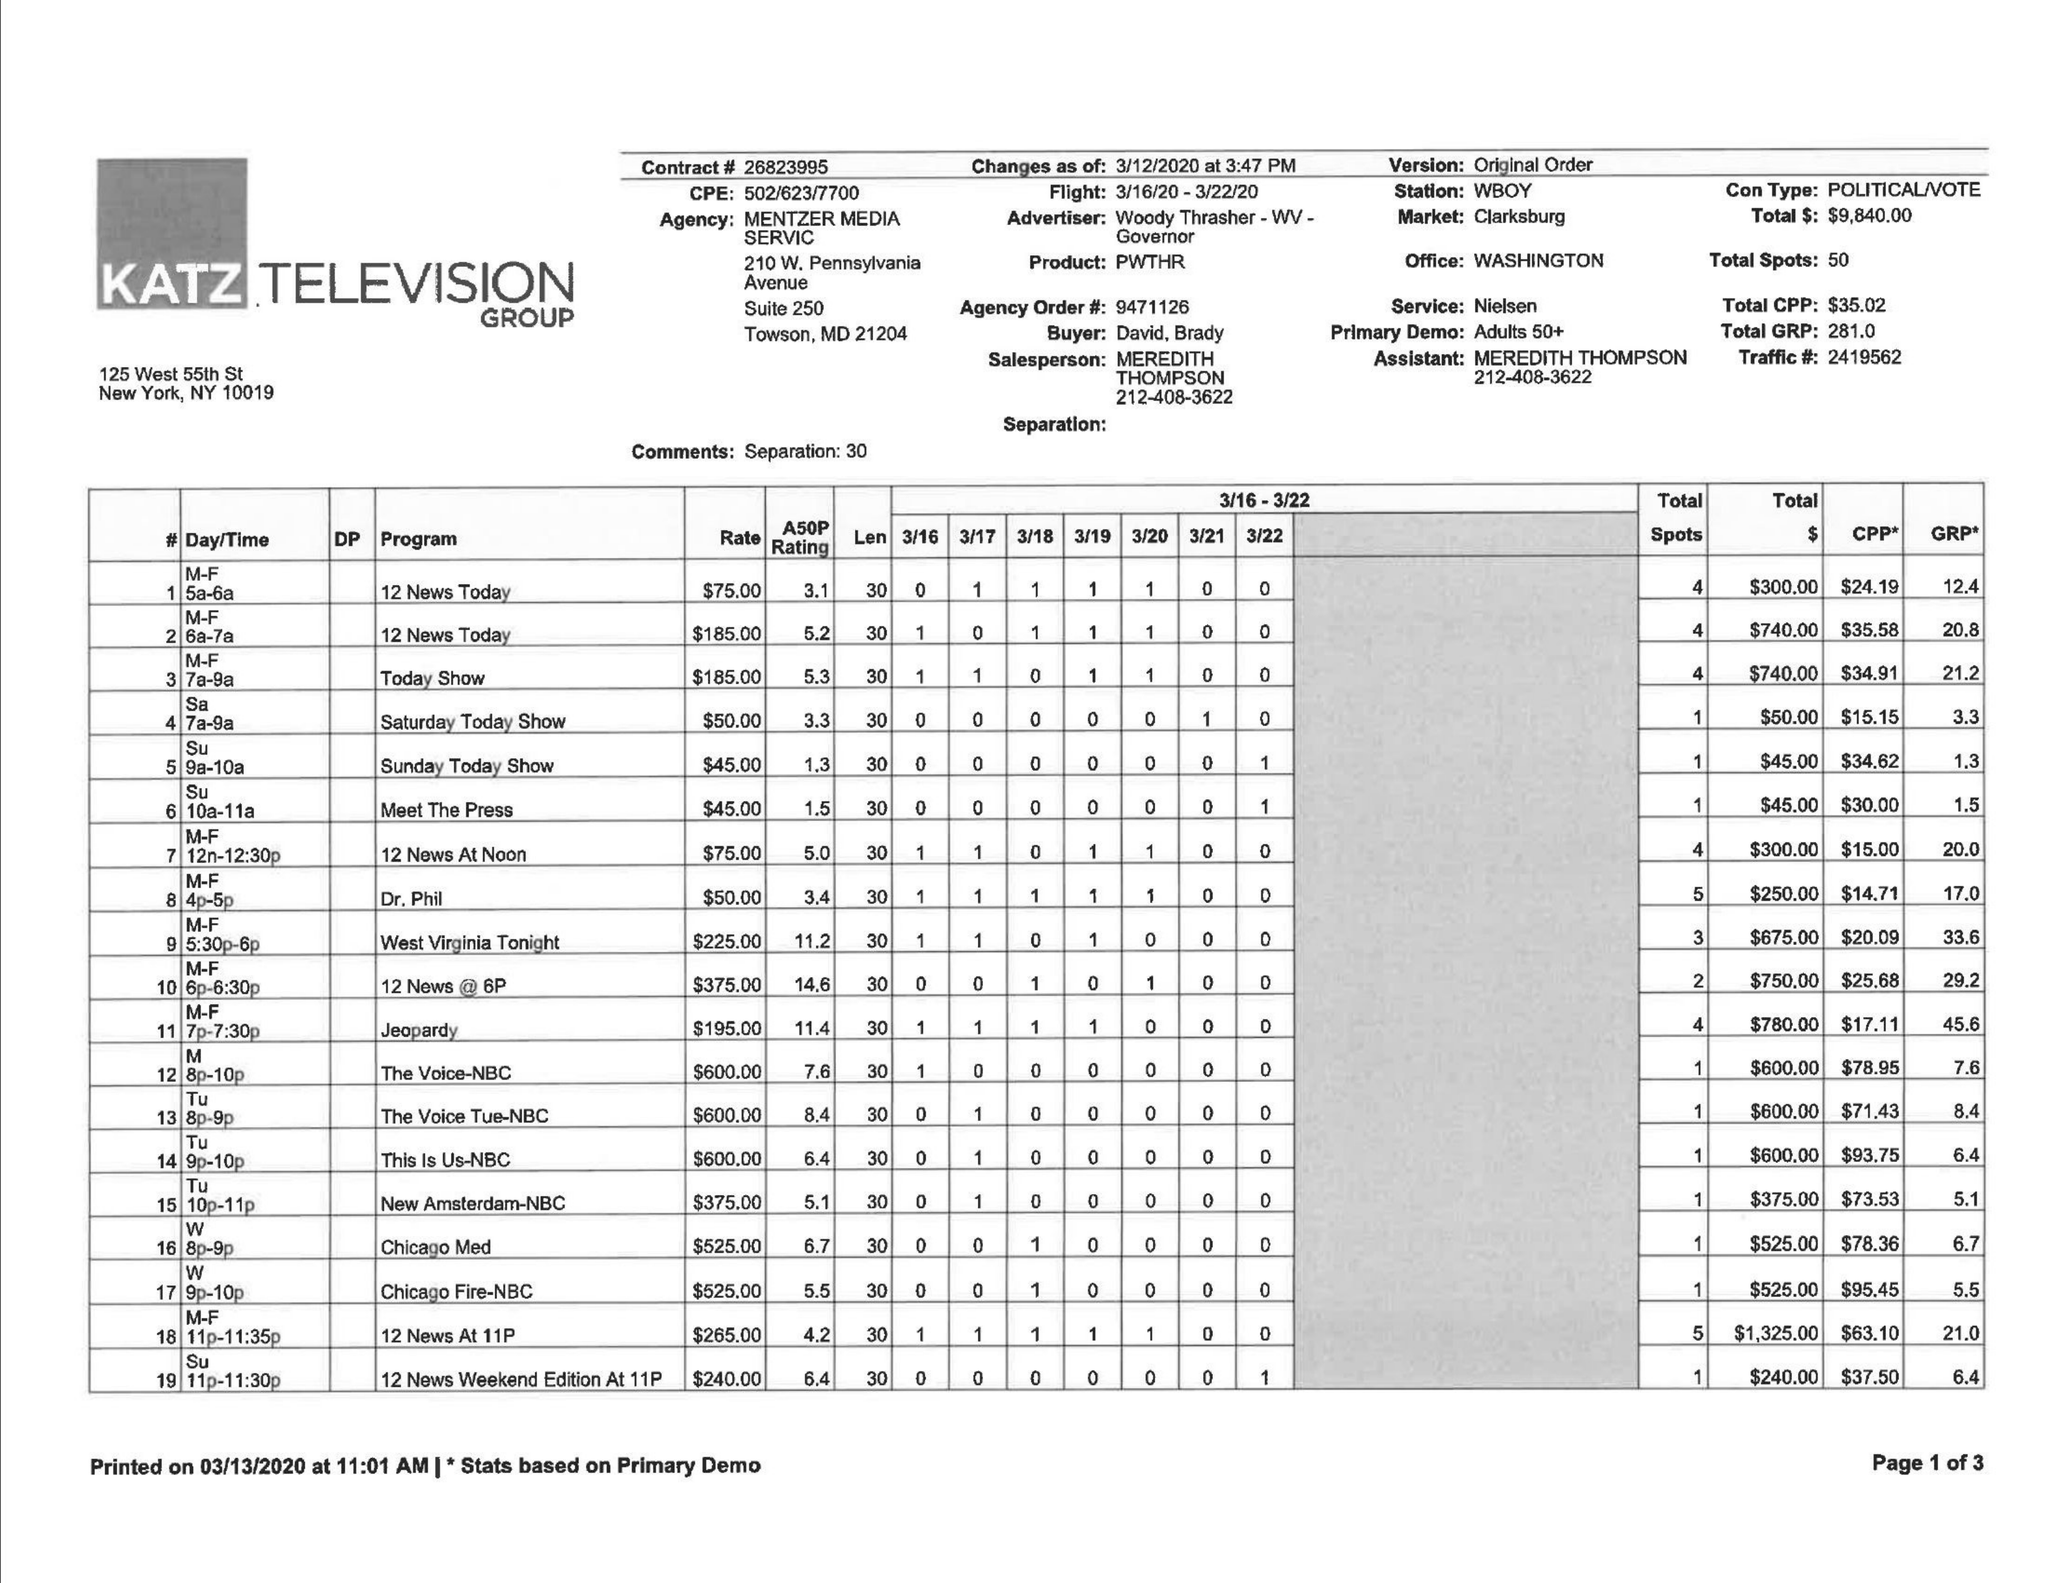What is the value for the advertiser?
Answer the question using a single word or phrase. WOODYTHRASHER -WV-  GOVERNOR 